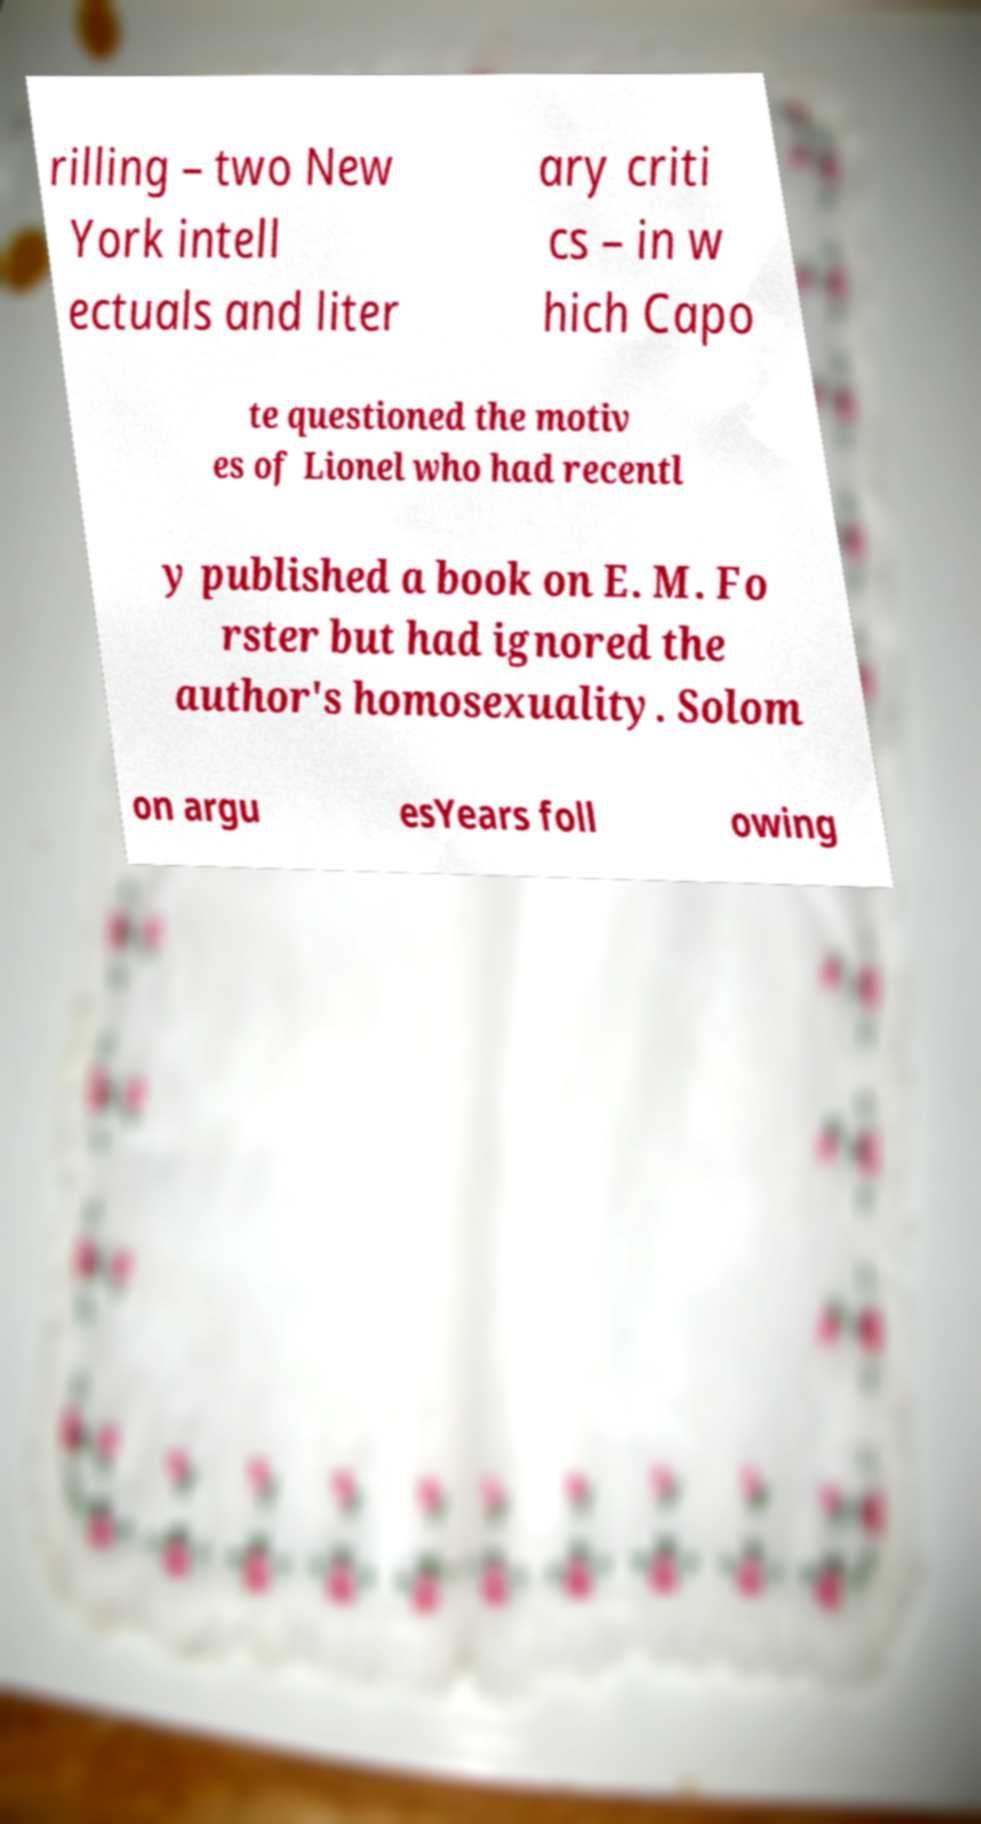For documentation purposes, I need the text within this image transcribed. Could you provide that? rilling – two New York intell ectuals and liter ary criti cs – in w hich Capo te questioned the motiv es of Lionel who had recentl y published a book on E. M. Fo rster but had ignored the author's homosexuality. Solom on argu esYears foll owing 